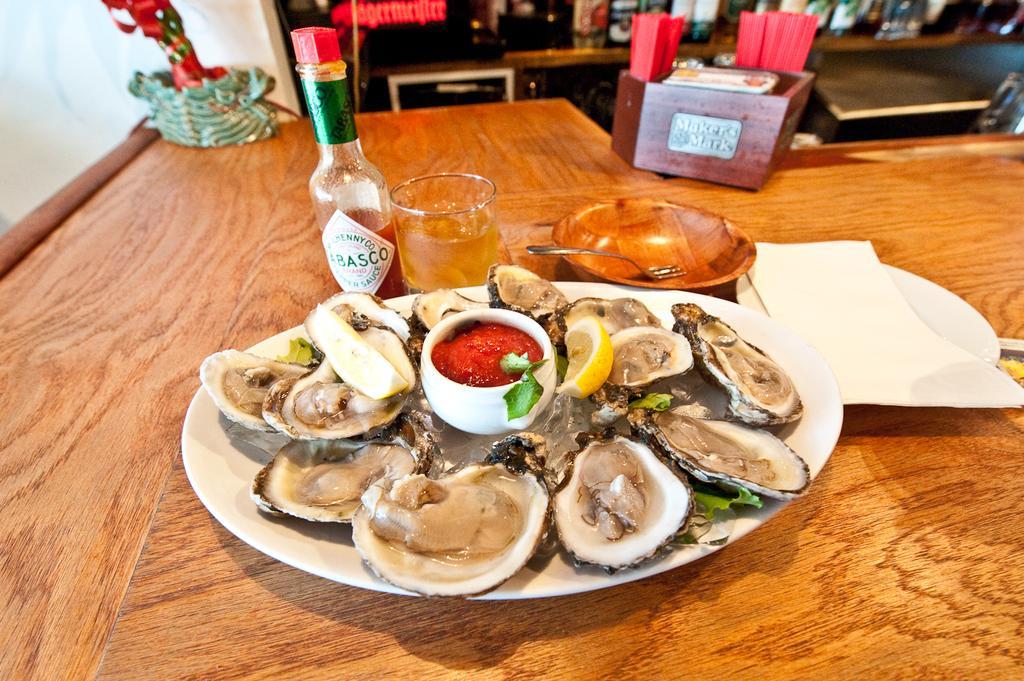In one or two sentences, can you explain what this image depicts? Here we can see snail on the shells,lemon slice,leaves and sauce in a cup on a plate on the table and there is a wine bottle,glass with liquid in it,fork in a bowl,tissue on a plate and other two objects. In the background there are bottles on a table,wall and other objects. 